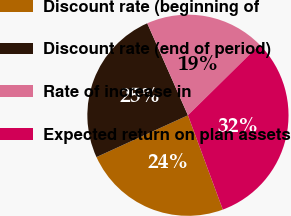<chart> <loc_0><loc_0><loc_500><loc_500><pie_chart><fcel>Discount rate (beginning of<fcel>Discount rate (end of period)<fcel>Rate of increase in<fcel>Expected return on plan assets<nl><fcel>23.81%<fcel>25.2%<fcel>19.25%<fcel>31.75%<nl></chart> 